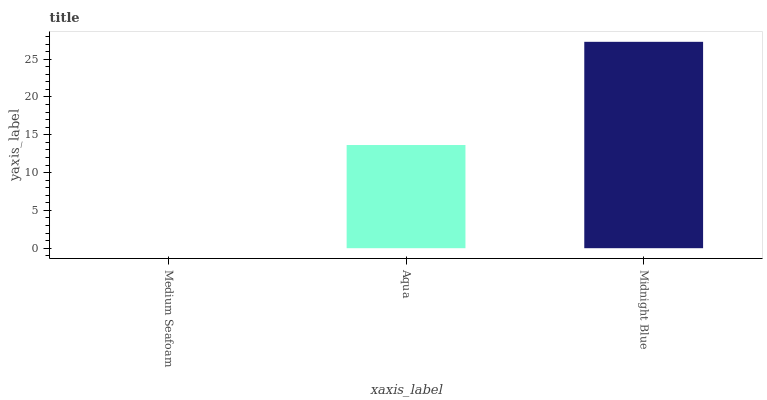Is Medium Seafoam the minimum?
Answer yes or no. Yes. Is Midnight Blue the maximum?
Answer yes or no. Yes. Is Aqua the minimum?
Answer yes or no. No. Is Aqua the maximum?
Answer yes or no. No. Is Aqua greater than Medium Seafoam?
Answer yes or no. Yes. Is Medium Seafoam less than Aqua?
Answer yes or no. Yes. Is Medium Seafoam greater than Aqua?
Answer yes or no. No. Is Aqua less than Medium Seafoam?
Answer yes or no. No. Is Aqua the high median?
Answer yes or no. Yes. Is Aqua the low median?
Answer yes or no. Yes. Is Midnight Blue the high median?
Answer yes or no. No. Is Medium Seafoam the low median?
Answer yes or no. No. 